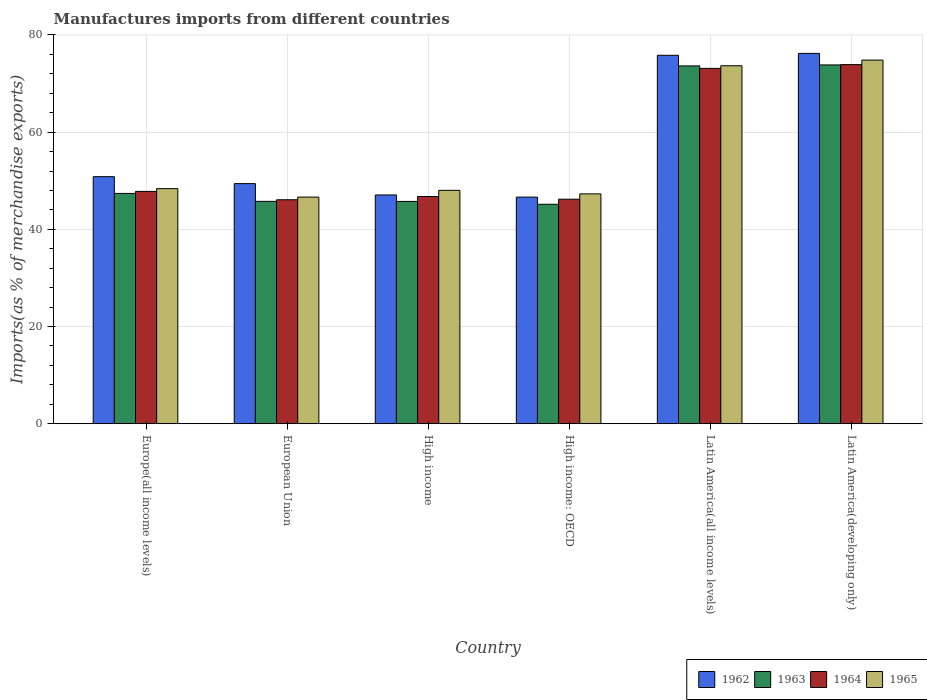How many different coloured bars are there?
Provide a succinct answer. 4. How many groups of bars are there?
Keep it short and to the point. 6. Are the number of bars per tick equal to the number of legend labels?
Your answer should be very brief. Yes. How many bars are there on the 4th tick from the left?
Offer a very short reply. 4. How many bars are there on the 1st tick from the right?
Give a very brief answer. 4. What is the label of the 6th group of bars from the left?
Provide a short and direct response. Latin America(developing only). In how many cases, is the number of bars for a given country not equal to the number of legend labels?
Provide a succinct answer. 0. What is the percentage of imports to different countries in 1964 in Latin America(all income levels)?
Offer a very short reply. 73.13. Across all countries, what is the maximum percentage of imports to different countries in 1965?
Your answer should be very brief. 74.83. Across all countries, what is the minimum percentage of imports to different countries in 1962?
Provide a succinct answer. 46.64. In which country was the percentage of imports to different countries in 1964 maximum?
Make the answer very short. Latin America(developing only). In which country was the percentage of imports to different countries in 1962 minimum?
Provide a short and direct response. High income: OECD. What is the total percentage of imports to different countries in 1963 in the graph?
Your response must be concise. 331.54. What is the difference between the percentage of imports to different countries in 1963 in Europe(all income levels) and that in High income?
Provide a succinct answer. 1.65. What is the difference between the percentage of imports to different countries in 1962 in Latin America(all income levels) and the percentage of imports to different countries in 1964 in High income?
Offer a terse response. 29.05. What is the average percentage of imports to different countries in 1962 per country?
Make the answer very short. 57.67. What is the difference between the percentage of imports to different countries of/in 1965 and percentage of imports to different countries of/in 1964 in European Union?
Provide a short and direct response. 0.55. In how many countries, is the percentage of imports to different countries in 1964 greater than 68 %?
Your response must be concise. 2. What is the ratio of the percentage of imports to different countries in 1962 in High income: OECD to that in Latin America(developing only)?
Give a very brief answer. 0.61. What is the difference between the highest and the second highest percentage of imports to different countries in 1963?
Your answer should be very brief. -0.2. What is the difference between the highest and the lowest percentage of imports to different countries in 1964?
Offer a terse response. 27.81. In how many countries, is the percentage of imports to different countries in 1962 greater than the average percentage of imports to different countries in 1962 taken over all countries?
Provide a succinct answer. 2. Is the sum of the percentage of imports to different countries in 1965 in European Union and Latin America(all income levels) greater than the maximum percentage of imports to different countries in 1962 across all countries?
Ensure brevity in your answer.  Yes. What does the 4th bar from the left in High income represents?
Make the answer very short. 1965. What does the 3rd bar from the right in High income: OECD represents?
Your answer should be very brief. 1963. Are all the bars in the graph horizontal?
Ensure brevity in your answer.  No. How many countries are there in the graph?
Ensure brevity in your answer.  6. Are the values on the major ticks of Y-axis written in scientific E-notation?
Offer a very short reply. No. Does the graph contain any zero values?
Offer a terse response. No. Does the graph contain grids?
Provide a succinct answer. Yes. Where does the legend appear in the graph?
Your response must be concise. Bottom right. How many legend labels are there?
Offer a terse response. 4. How are the legend labels stacked?
Your answer should be very brief. Horizontal. What is the title of the graph?
Your response must be concise. Manufactures imports from different countries. What is the label or title of the Y-axis?
Keep it short and to the point. Imports(as % of merchandise exports). What is the Imports(as % of merchandise exports) in 1962 in Europe(all income levels)?
Your answer should be very brief. 50.84. What is the Imports(as % of merchandise exports) in 1963 in Europe(all income levels)?
Provide a succinct answer. 47.4. What is the Imports(as % of merchandise exports) of 1964 in Europe(all income levels)?
Ensure brevity in your answer.  47.81. What is the Imports(as % of merchandise exports) in 1965 in Europe(all income levels)?
Offer a very short reply. 48.38. What is the Imports(as % of merchandise exports) in 1962 in European Union?
Your answer should be very brief. 49.41. What is the Imports(as % of merchandise exports) in 1963 in European Union?
Offer a very short reply. 45.76. What is the Imports(as % of merchandise exports) of 1964 in European Union?
Your answer should be very brief. 46.09. What is the Imports(as % of merchandise exports) of 1965 in European Union?
Your answer should be compact. 46.64. What is the Imports(as % of merchandise exports) in 1962 in High income?
Provide a short and direct response. 47.08. What is the Imports(as % of merchandise exports) of 1963 in High income?
Provide a short and direct response. 45.75. What is the Imports(as % of merchandise exports) in 1964 in High income?
Your response must be concise. 46.77. What is the Imports(as % of merchandise exports) of 1965 in High income?
Your answer should be compact. 48.04. What is the Imports(as % of merchandise exports) in 1962 in High income: OECD?
Offer a terse response. 46.64. What is the Imports(as % of merchandise exports) in 1963 in High income: OECD?
Your answer should be compact. 45.16. What is the Imports(as % of merchandise exports) of 1964 in High income: OECD?
Provide a succinct answer. 46.21. What is the Imports(as % of merchandise exports) of 1965 in High income: OECD?
Provide a short and direct response. 47.3. What is the Imports(as % of merchandise exports) in 1962 in Latin America(all income levels)?
Offer a terse response. 75.82. What is the Imports(as % of merchandise exports) in 1963 in Latin America(all income levels)?
Keep it short and to the point. 73.64. What is the Imports(as % of merchandise exports) of 1964 in Latin America(all income levels)?
Ensure brevity in your answer.  73.13. What is the Imports(as % of merchandise exports) of 1965 in Latin America(all income levels)?
Provide a short and direct response. 73.67. What is the Imports(as % of merchandise exports) of 1962 in Latin America(developing only)?
Offer a very short reply. 76.21. What is the Imports(as % of merchandise exports) in 1963 in Latin America(developing only)?
Offer a terse response. 73.84. What is the Imports(as % of merchandise exports) of 1964 in Latin America(developing only)?
Provide a succinct answer. 73.9. What is the Imports(as % of merchandise exports) of 1965 in Latin America(developing only)?
Ensure brevity in your answer.  74.83. Across all countries, what is the maximum Imports(as % of merchandise exports) of 1962?
Your answer should be compact. 76.21. Across all countries, what is the maximum Imports(as % of merchandise exports) in 1963?
Your response must be concise. 73.84. Across all countries, what is the maximum Imports(as % of merchandise exports) of 1964?
Your response must be concise. 73.9. Across all countries, what is the maximum Imports(as % of merchandise exports) of 1965?
Provide a short and direct response. 74.83. Across all countries, what is the minimum Imports(as % of merchandise exports) in 1962?
Provide a short and direct response. 46.64. Across all countries, what is the minimum Imports(as % of merchandise exports) of 1963?
Your response must be concise. 45.16. Across all countries, what is the minimum Imports(as % of merchandise exports) of 1964?
Your response must be concise. 46.09. Across all countries, what is the minimum Imports(as % of merchandise exports) of 1965?
Offer a very short reply. 46.64. What is the total Imports(as % of merchandise exports) of 1962 in the graph?
Provide a succinct answer. 346. What is the total Imports(as % of merchandise exports) in 1963 in the graph?
Your answer should be compact. 331.54. What is the total Imports(as % of merchandise exports) in 1964 in the graph?
Keep it short and to the point. 333.9. What is the total Imports(as % of merchandise exports) of 1965 in the graph?
Provide a short and direct response. 338.86. What is the difference between the Imports(as % of merchandise exports) in 1962 in Europe(all income levels) and that in European Union?
Offer a very short reply. 1.43. What is the difference between the Imports(as % of merchandise exports) in 1963 in Europe(all income levels) and that in European Union?
Ensure brevity in your answer.  1.63. What is the difference between the Imports(as % of merchandise exports) in 1964 in Europe(all income levels) and that in European Union?
Your answer should be very brief. 1.72. What is the difference between the Imports(as % of merchandise exports) in 1965 in Europe(all income levels) and that in European Union?
Offer a terse response. 1.74. What is the difference between the Imports(as % of merchandise exports) in 1962 in Europe(all income levels) and that in High income?
Keep it short and to the point. 3.76. What is the difference between the Imports(as % of merchandise exports) of 1963 in Europe(all income levels) and that in High income?
Offer a terse response. 1.65. What is the difference between the Imports(as % of merchandise exports) in 1964 in Europe(all income levels) and that in High income?
Make the answer very short. 1.05. What is the difference between the Imports(as % of merchandise exports) in 1965 in Europe(all income levels) and that in High income?
Offer a very short reply. 0.35. What is the difference between the Imports(as % of merchandise exports) in 1962 in Europe(all income levels) and that in High income: OECD?
Give a very brief answer. 4.21. What is the difference between the Imports(as % of merchandise exports) of 1963 in Europe(all income levels) and that in High income: OECD?
Provide a succinct answer. 2.23. What is the difference between the Imports(as % of merchandise exports) in 1964 in Europe(all income levels) and that in High income: OECD?
Provide a short and direct response. 1.61. What is the difference between the Imports(as % of merchandise exports) of 1965 in Europe(all income levels) and that in High income: OECD?
Your answer should be very brief. 1.08. What is the difference between the Imports(as % of merchandise exports) of 1962 in Europe(all income levels) and that in Latin America(all income levels)?
Your answer should be very brief. -24.98. What is the difference between the Imports(as % of merchandise exports) in 1963 in Europe(all income levels) and that in Latin America(all income levels)?
Ensure brevity in your answer.  -26.24. What is the difference between the Imports(as % of merchandise exports) of 1964 in Europe(all income levels) and that in Latin America(all income levels)?
Keep it short and to the point. -25.31. What is the difference between the Imports(as % of merchandise exports) in 1965 in Europe(all income levels) and that in Latin America(all income levels)?
Offer a terse response. -25.29. What is the difference between the Imports(as % of merchandise exports) in 1962 in Europe(all income levels) and that in Latin America(developing only)?
Your answer should be compact. -25.37. What is the difference between the Imports(as % of merchandise exports) in 1963 in Europe(all income levels) and that in Latin America(developing only)?
Make the answer very short. -26.44. What is the difference between the Imports(as % of merchandise exports) of 1964 in Europe(all income levels) and that in Latin America(developing only)?
Keep it short and to the point. -26.09. What is the difference between the Imports(as % of merchandise exports) in 1965 in Europe(all income levels) and that in Latin America(developing only)?
Provide a succinct answer. -26.45. What is the difference between the Imports(as % of merchandise exports) in 1962 in European Union and that in High income?
Keep it short and to the point. 2.33. What is the difference between the Imports(as % of merchandise exports) in 1963 in European Union and that in High income?
Your answer should be very brief. 0.02. What is the difference between the Imports(as % of merchandise exports) of 1964 in European Union and that in High income?
Make the answer very short. -0.68. What is the difference between the Imports(as % of merchandise exports) in 1965 in European Union and that in High income?
Make the answer very short. -1.4. What is the difference between the Imports(as % of merchandise exports) in 1962 in European Union and that in High income: OECD?
Ensure brevity in your answer.  2.78. What is the difference between the Imports(as % of merchandise exports) in 1963 in European Union and that in High income: OECD?
Your answer should be compact. 0.6. What is the difference between the Imports(as % of merchandise exports) in 1964 in European Union and that in High income: OECD?
Your answer should be compact. -0.12. What is the difference between the Imports(as % of merchandise exports) of 1965 in European Union and that in High income: OECD?
Provide a succinct answer. -0.67. What is the difference between the Imports(as % of merchandise exports) in 1962 in European Union and that in Latin America(all income levels)?
Provide a succinct answer. -26.4. What is the difference between the Imports(as % of merchandise exports) in 1963 in European Union and that in Latin America(all income levels)?
Keep it short and to the point. -27.87. What is the difference between the Imports(as % of merchandise exports) in 1964 in European Union and that in Latin America(all income levels)?
Keep it short and to the point. -27.04. What is the difference between the Imports(as % of merchandise exports) of 1965 in European Union and that in Latin America(all income levels)?
Keep it short and to the point. -27.03. What is the difference between the Imports(as % of merchandise exports) of 1962 in European Union and that in Latin America(developing only)?
Keep it short and to the point. -26.8. What is the difference between the Imports(as % of merchandise exports) of 1963 in European Union and that in Latin America(developing only)?
Give a very brief answer. -28.07. What is the difference between the Imports(as % of merchandise exports) in 1964 in European Union and that in Latin America(developing only)?
Provide a short and direct response. -27.81. What is the difference between the Imports(as % of merchandise exports) in 1965 in European Union and that in Latin America(developing only)?
Your response must be concise. -28.19. What is the difference between the Imports(as % of merchandise exports) of 1962 in High income and that in High income: OECD?
Ensure brevity in your answer.  0.44. What is the difference between the Imports(as % of merchandise exports) of 1963 in High income and that in High income: OECD?
Ensure brevity in your answer.  0.58. What is the difference between the Imports(as % of merchandise exports) in 1964 in High income and that in High income: OECD?
Offer a very short reply. 0.56. What is the difference between the Imports(as % of merchandise exports) of 1965 in High income and that in High income: OECD?
Offer a terse response. 0.73. What is the difference between the Imports(as % of merchandise exports) in 1962 in High income and that in Latin America(all income levels)?
Make the answer very short. -28.74. What is the difference between the Imports(as % of merchandise exports) of 1963 in High income and that in Latin America(all income levels)?
Your answer should be very brief. -27.89. What is the difference between the Imports(as % of merchandise exports) of 1964 in High income and that in Latin America(all income levels)?
Provide a succinct answer. -26.36. What is the difference between the Imports(as % of merchandise exports) of 1965 in High income and that in Latin America(all income levels)?
Make the answer very short. -25.63. What is the difference between the Imports(as % of merchandise exports) of 1962 in High income and that in Latin America(developing only)?
Provide a short and direct response. -29.13. What is the difference between the Imports(as % of merchandise exports) in 1963 in High income and that in Latin America(developing only)?
Offer a terse response. -28.09. What is the difference between the Imports(as % of merchandise exports) in 1964 in High income and that in Latin America(developing only)?
Make the answer very short. -27.13. What is the difference between the Imports(as % of merchandise exports) of 1965 in High income and that in Latin America(developing only)?
Give a very brief answer. -26.8. What is the difference between the Imports(as % of merchandise exports) of 1962 in High income: OECD and that in Latin America(all income levels)?
Keep it short and to the point. -29.18. What is the difference between the Imports(as % of merchandise exports) of 1963 in High income: OECD and that in Latin America(all income levels)?
Ensure brevity in your answer.  -28.47. What is the difference between the Imports(as % of merchandise exports) in 1964 in High income: OECD and that in Latin America(all income levels)?
Provide a succinct answer. -26.92. What is the difference between the Imports(as % of merchandise exports) in 1965 in High income: OECD and that in Latin America(all income levels)?
Offer a very short reply. -26.36. What is the difference between the Imports(as % of merchandise exports) of 1962 in High income: OECD and that in Latin America(developing only)?
Your answer should be very brief. -29.58. What is the difference between the Imports(as % of merchandise exports) in 1963 in High income: OECD and that in Latin America(developing only)?
Give a very brief answer. -28.67. What is the difference between the Imports(as % of merchandise exports) of 1964 in High income: OECD and that in Latin America(developing only)?
Your answer should be compact. -27.69. What is the difference between the Imports(as % of merchandise exports) of 1965 in High income: OECD and that in Latin America(developing only)?
Keep it short and to the point. -27.53. What is the difference between the Imports(as % of merchandise exports) of 1962 in Latin America(all income levels) and that in Latin America(developing only)?
Give a very brief answer. -0.39. What is the difference between the Imports(as % of merchandise exports) in 1963 in Latin America(all income levels) and that in Latin America(developing only)?
Offer a terse response. -0.2. What is the difference between the Imports(as % of merchandise exports) in 1964 in Latin America(all income levels) and that in Latin America(developing only)?
Your response must be concise. -0.77. What is the difference between the Imports(as % of merchandise exports) in 1965 in Latin America(all income levels) and that in Latin America(developing only)?
Ensure brevity in your answer.  -1.16. What is the difference between the Imports(as % of merchandise exports) in 1962 in Europe(all income levels) and the Imports(as % of merchandise exports) in 1963 in European Union?
Offer a terse response. 5.08. What is the difference between the Imports(as % of merchandise exports) of 1962 in Europe(all income levels) and the Imports(as % of merchandise exports) of 1964 in European Union?
Your response must be concise. 4.75. What is the difference between the Imports(as % of merchandise exports) of 1962 in Europe(all income levels) and the Imports(as % of merchandise exports) of 1965 in European Union?
Offer a very short reply. 4.2. What is the difference between the Imports(as % of merchandise exports) of 1963 in Europe(all income levels) and the Imports(as % of merchandise exports) of 1964 in European Union?
Provide a short and direct response. 1.31. What is the difference between the Imports(as % of merchandise exports) of 1963 in Europe(all income levels) and the Imports(as % of merchandise exports) of 1965 in European Union?
Offer a very short reply. 0.76. What is the difference between the Imports(as % of merchandise exports) of 1964 in Europe(all income levels) and the Imports(as % of merchandise exports) of 1965 in European Union?
Your answer should be compact. 1.18. What is the difference between the Imports(as % of merchandise exports) of 1962 in Europe(all income levels) and the Imports(as % of merchandise exports) of 1963 in High income?
Provide a succinct answer. 5.1. What is the difference between the Imports(as % of merchandise exports) of 1962 in Europe(all income levels) and the Imports(as % of merchandise exports) of 1964 in High income?
Keep it short and to the point. 4.08. What is the difference between the Imports(as % of merchandise exports) in 1962 in Europe(all income levels) and the Imports(as % of merchandise exports) in 1965 in High income?
Give a very brief answer. 2.81. What is the difference between the Imports(as % of merchandise exports) of 1963 in Europe(all income levels) and the Imports(as % of merchandise exports) of 1964 in High income?
Offer a very short reply. 0.63. What is the difference between the Imports(as % of merchandise exports) in 1963 in Europe(all income levels) and the Imports(as % of merchandise exports) in 1965 in High income?
Offer a very short reply. -0.64. What is the difference between the Imports(as % of merchandise exports) in 1964 in Europe(all income levels) and the Imports(as % of merchandise exports) in 1965 in High income?
Provide a succinct answer. -0.22. What is the difference between the Imports(as % of merchandise exports) in 1962 in Europe(all income levels) and the Imports(as % of merchandise exports) in 1963 in High income: OECD?
Provide a succinct answer. 5.68. What is the difference between the Imports(as % of merchandise exports) in 1962 in Europe(all income levels) and the Imports(as % of merchandise exports) in 1964 in High income: OECD?
Your answer should be very brief. 4.63. What is the difference between the Imports(as % of merchandise exports) of 1962 in Europe(all income levels) and the Imports(as % of merchandise exports) of 1965 in High income: OECD?
Give a very brief answer. 3.54. What is the difference between the Imports(as % of merchandise exports) in 1963 in Europe(all income levels) and the Imports(as % of merchandise exports) in 1964 in High income: OECD?
Make the answer very short. 1.19. What is the difference between the Imports(as % of merchandise exports) of 1963 in Europe(all income levels) and the Imports(as % of merchandise exports) of 1965 in High income: OECD?
Keep it short and to the point. 0.09. What is the difference between the Imports(as % of merchandise exports) in 1964 in Europe(all income levels) and the Imports(as % of merchandise exports) in 1965 in High income: OECD?
Offer a very short reply. 0.51. What is the difference between the Imports(as % of merchandise exports) of 1962 in Europe(all income levels) and the Imports(as % of merchandise exports) of 1963 in Latin America(all income levels)?
Provide a short and direct response. -22.79. What is the difference between the Imports(as % of merchandise exports) in 1962 in Europe(all income levels) and the Imports(as % of merchandise exports) in 1964 in Latin America(all income levels)?
Keep it short and to the point. -22.28. What is the difference between the Imports(as % of merchandise exports) in 1962 in Europe(all income levels) and the Imports(as % of merchandise exports) in 1965 in Latin America(all income levels)?
Keep it short and to the point. -22.83. What is the difference between the Imports(as % of merchandise exports) in 1963 in Europe(all income levels) and the Imports(as % of merchandise exports) in 1964 in Latin America(all income levels)?
Ensure brevity in your answer.  -25.73. What is the difference between the Imports(as % of merchandise exports) of 1963 in Europe(all income levels) and the Imports(as % of merchandise exports) of 1965 in Latin America(all income levels)?
Provide a short and direct response. -26.27. What is the difference between the Imports(as % of merchandise exports) of 1964 in Europe(all income levels) and the Imports(as % of merchandise exports) of 1965 in Latin America(all income levels)?
Give a very brief answer. -25.86. What is the difference between the Imports(as % of merchandise exports) in 1962 in Europe(all income levels) and the Imports(as % of merchandise exports) in 1963 in Latin America(developing only)?
Your response must be concise. -23. What is the difference between the Imports(as % of merchandise exports) in 1962 in Europe(all income levels) and the Imports(as % of merchandise exports) in 1964 in Latin America(developing only)?
Provide a short and direct response. -23.06. What is the difference between the Imports(as % of merchandise exports) of 1962 in Europe(all income levels) and the Imports(as % of merchandise exports) of 1965 in Latin America(developing only)?
Your response must be concise. -23.99. What is the difference between the Imports(as % of merchandise exports) in 1963 in Europe(all income levels) and the Imports(as % of merchandise exports) in 1964 in Latin America(developing only)?
Provide a succinct answer. -26.5. What is the difference between the Imports(as % of merchandise exports) of 1963 in Europe(all income levels) and the Imports(as % of merchandise exports) of 1965 in Latin America(developing only)?
Your answer should be compact. -27.44. What is the difference between the Imports(as % of merchandise exports) of 1964 in Europe(all income levels) and the Imports(as % of merchandise exports) of 1965 in Latin America(developing only)?
Offer a very short reply. -27.02. What is the difference between the Imports(as % of merchandise exports) in 1962 in European Union and the Imports(as % of merchandise exports) in 1963 in High income?
Your response must be concise. 3.67. What is the difference between the Imports(as % of merchandise exports) of 1962 in European Union and the Imports(as % of merchandise exports) of 1964 in High income?
Keep it short and to the point. 2.65. What is the difference between the Imports(as % of merchandise exports) of 1962 in European Union and the Imports(as % of merchandise exports) of 1965 in High income?
Give a very brief answer. 1.38. What is the difference between the Imports(as % of merchandise exports) in 1963 in European Union and the Imports(as % of merchandise exports) in 1964 in High income?
Ensure brevity in your answer.  -1. What is the difference between the Imports(as % of merchandise exports) of 1963 in European Union and the Imports(as % of merchandise exports) of 1965 in High income?
Make the answer very short. -2.27. What is the difference between the Imports(as % of merchandise exports) in 1964 in European Union and the Imports(as % of merchandise exports) in 1965 in High income?
Offer a terse response. -1.94. What is the difference between the Imports(as % of merchandise exports) of 1962 in European Union and the Imports(as % of merchandise exports) of 1963 in High income: OECD?
Make the answer very short. 4.25. What is the difference between the Imports(as % of merchandise exports) of 1962 in European Union and the Imports(as % of merchandise exports) of 1964 in High income: OECD?
Your answer should be compact. 3.21. What is the difference between the Imports(as % of merchandise exports) of 1962 in European Union and the Imports(as % of merchandise exports) of 1965 in High income: OECD?
Offer a very short reply. 2.11. What is the difference between the Imports(as % of merchandise exports) of 1963 in European Union and the Imports(as % of merchandise exports) of 1964 in High income: OECD?
Make the answer very short. -0.44. What is the difference between the Imports(as % of merchandise exports) in 1963 in European Union and the Imports(as % of merchandise exports) in 1965 in High income: OECD?
Provide a succinct answer. -1.54. What is the difference between the Imports(as % of merchandise exports) in 1964 in European Union and the Imports(as % of merchandise exports) in 1965 in High income: OECD?
Provide a short and direct response. -1.21. What is the difference between the Imports(as % of merchandise exports) of 1962 in European Union and the Imports(as % of merchandise exports) of 1963 in Latin America(all income levels)?
Give a very brief answer. -24.22. What is the difference between the Imports(as % of merchandise exports) of 1962 in European Union and the Imports(as % of merchandise exports) of 1964 in Latin America(all income levels)?
Your answer should be very brief. -23.71. What is the difference between the Imports(as % of merchandise exports) in 1962 in European Union and the Imports(as % of merchandise exports) in 1965 in Latin America(all income levels)?
Keep it short and to the point. -24.25. What is the difference between the Imports(as % of merchandise exports) in 1963 in European Union and the Imports(as % of merchandise exports) in 1964 in Latin America(all income levels)?
Offer a very short reply. -27.36. What is the difference between the Imports(as % of merchandise exports) in 1963 in European Union and the Imports(as % of merchandise exports) in 1965 in Latin America(all income levels)?
Make the answer very short. -27.91. What is the difference between the Imports(as % of merchandise exports) of 1964 in European Union and the Imports(as % of merchandise exports) of 1965 in Latin America(all income levels)?
Your answer should be compact. -27.58. What is the difference between the Imports(as % of merchandise exports) in 1962 in European Union and the Imports(as % of merchandise exports) in 1963 in Latin America(developing only)?
Provide a succinct answer. -24.42. What is the difference between the Imports(as % of merchandise exports) of 1962 in European Union and the Imports(as % of merchandise exports) of 1964 in Latin America(developing only)?
Make the answer very short. -24.49. What is the difference between the Imports(as % of merchandise exports) in 1962 in European Union and the Imports(as % of merchandise exports) in 1965 in Latin America(developing only)?
Provide a short and direct response. -25.42. What is the difference between the Imports(as % of merchandise exports) of 1963 in European Union and the Imports(as % of merchandise exports) of 1964 in Latin America(developing only)?
Your answer should be very brief. -28.14. What is the difference between the Imports(as % of merchandise exports) in 1963 in European Union and the Imports(as % of merchandise exports) in 1965 in Latin America(developing only)?
Your response must be concise. -29.07. What is the difference between the Imports(as % of merchandise exports) in 1964 in European Union and the Imports(as % of merchandise exports) in 1965 in Latin America(developing only)?
Provide a succinct answer. -28.74. What is the difference between the Imports(as % of merchandise exports) of 1962 in High income and the Imports(as % of merchandise exports) of 1963 in High income: OECD?
Give a very brief answer. 1.92. What is the difference between the Imports(as % of merchandise exports) in 1962 in High income and the Imports(as % of merchandise exports) in 1964 in High income: OECD?
Make the answer very short. 0.87. What is the difference between the Imports(as % of merchandise exports) of 1962 in High income and the Imports(as % of merchandise exports) of 1965 in High income: OECD?
Provide a succinct answer. -0.22. What is the difference between the Imports(as % of merchandise exports) of 1963 in High income and the Imports(as % of merchandise exports) of 1964 in High income: OECD?
Your response must be concise. -0.46. What is the difference between the Imports(as % of merchandise exports) of 1963 in High income and the Imports(as % of merchandise exports) of 1965 in High income: OECD?
Offer a very short reply. -1.56. What is the difference between the Imports(as % of merchandise exports) in 1964 in High income and the Imports(as % of merchandise exports) in 1965 in High income: OECD?
Your response must be concise. -0.54. What is the difference between the Imports(as % of merchandise exports) in 1962 in High income and the Imports(as % of merchandise exports) in 1963 in Latin America(all income levels)?
Keep it short and to the point. -26.56. What is the difference between the Imports(as % of merchandise exports) in 1962 in High income and the Imports(as % of merchandise exports) in 1964 in Latin America(all income levels)?
Make the answer very short. -26.05. What is the difference between the Imports(as % of merchandise exports) of 1962 in High income and the Imports(as % of merchandise exports) of 1965 in Latin America(all income levels)?
Your response must be concise. -26.59. What is the difference between the Imports(as % of merchandise exports) of 1963 in High income and the Imports(as % of merchandise exports) of 1964 in Latin America(all income levels)?
Your answer should be compact. -27.38. What is the difference between the Imports(as % of merchandise exports) of 1963 in High income and the Imports(as % of merchandise exports) of 1965 in Latin America(all income levels)?
Provide a succinct answer. -27.92. What is the difference between the Imports(as % of merchandise exports) in 1964 in High income and the Imports(as % of merchandise exports) in 1965 in Latin America(all income levels)?
Keep it short and to the point. -26.9. What is the difference between the Imports(as % of merchandise exports) of 1962 in High income and the Imports(as % of merchandise exports) of 1963 in Latin America(developing only)?
Your response must be concise. -26.76. What is the difference between the Imports(as % of merchandise exports) in 1962 in High income and the Imports(as % of merchandise exports) in 1964 in Latin America(developing only)?
Keep it short and to the point. -26.82. What is the difference between the Imports(as % of merchandise exports) of 1962 in High income and the Imports(as % of merchandise exports) of 1965 in Latin America(developing only)?
Make the answer very short. -27.75. What is the difference between the Imports(as % of merchandise exports) in 1963 in High income and the Imports(as % of merchandise exports) in 1964 in Latin America(developing only)?
Your answer should be compact. -28.15. What is the difference between the Imports(as % of merchandise exports) in 1963 in High income and the Imports(as % of merchandise exports) in 1965 in Latin America(developing only)?
Keep it short and to the point. -29.09. What is the difference between the Imports(as % of merchandise exports) of 1964 in High income and the Imports(as % of merchandise exports) of 1965 in Latin America(developing only)?
Provide a short and direct response. -28.07. What is the difference between the Imports(as % of merchandise exports) of 1962 in High income: OECD and the Imports(as % of merchandise exports) of 1964 in Latin America(all income levels)?
Your response must be concise. -26.49. What is the difference between the Imports(as % of merchandise exports) of 1962 in High income: OECD and the Imports(as % of merchandise exports) of 1965 in Latin America(all income levels)?
Ensure brevity in your answer.  -27.03. What is the difference between the Imports(as % of merchandise exports) of 1963 in High income: OECD and the Imports(as % of merchandise exports) of 1964 in Latin America(all income levels)?
Your answer should be compact. -27.96. What is the difference between the Imports(as % of merchandise exports) in 1963 in High income: OECD and the Imports(as % of merchandise exports) in 1965 in Latin America(all income levels)?
Offer a very short reply. -28.5. What is the difference between the Imports(as % of merchandise exports) in 1964 in High income: OECD and the Imports(as % of merchandise exports) in 1965 in Latin America(all income levels)?
Offer a terse response. -27.46. What is the difference between the Imports(as % of merchandise exports) in 1962 in High income: OECD and the Imports(as % of merchandise exports) in 1963 in Latin America(developing only)?
Keep it short and to the point. -27.2. What is the difference between the Imports(as % of merchandise exports) of 1962 in High income: OECD and the Imports(as % of merchandise exports) of 1964 in Latin America(developing only)?
Your answer should be compact. -27.26. What is the difference between the Imports(as % of merchandise exports) of 1962 in High income: OECD and the Imports(as % of merchandise exports) of 1965 in Latin America(developing only)?
Provide a short and direct response. -28.2. What is the difference between the Imports(as % of merchandise exports) of 1963 in High income: OECD and the Imports(as % of merchandise exports) of 1964 in Latin America(developing only)?
Give a very brief answer. -28.74. What is the difference between the Imports(as % of merchandise exports) of 1963 in High income: OECD and the Imports(as % of merchandise exports) of 1965 in Latin America(developing only)?
Your answer should be compact. -29.67. What is the difference between the Imports(as % of merchandise exports) in 1964 in High income: OECD and the Imports(as % of merchandise exports) in 1965 in Latin America(developing only)?
Offer a terse response. -28.62. What is the difference between the Imports(as % of merchandise exports) in 1962 in Latin America(all income levels) and the Imports(as % of merchandise exports) in 1963 in Latin America(developing only)?
Give a very brief answer. 1.98. What is the difference between the Imports(as % of merchandise exports) of 1962 in Latin America(all income levels) and the Imports(as % of merchandise exports) of 1964 in Latin America(developing only)?
Ensure brevity in your answer.  1.92. What is the difference between the Imports(as % of merchandise exports) in 1962 in Latin America(all income levels) and the Imports(as % of merchandise exports) in 1965 in Latin America(developing only)?
Keep it short and to the point. 0.99. What is the difference between the Imports(as % of merchandise exports) of 1963 in Latin America(all income levels) and the Imports(as % of merchandise exports) of 1964 in Latin America(developing only)?
Your response must be concise. -0.26. What is the difference between the Imports(as % of merchandise exports) of 1963 in Latin America(all income levels) and the Imports(as % of merchandise exports) of 1965 in Latin America(developing only)?
Provide a succinct answer. -1.2. What is the difference between the Imports(as % of merchandise exports) of 1964 in Latin America(all income levels) and the Imports(as % of merchandise exports) of 1965 in Latin America(developing only)?
Offer a very short reply. -1.71. What is the average Imports(as % of merchandise exports) in 1962 per country?
Provide a short and direct response. 57.67. What is the average Imports(as % of merchandise exports) in 1963 per country?
Your response must be concise. 55.26. What is the average Imports(as % of merchandise exports) of 1964 per country?
Your answer should be very brief. 55.65. What is the average Imports(as % of merchandise exports) of 1965 per country?
Give a very brief answer. 56.48. What is the difference between the Imports(as % of merchandise exports) in 1962 and Imports(as % of merchandise exports) in 1963 in Europe(all income levels)?
Ensure brevity in your answer.  3.45. What is the difference between the Imports(as % of merchandise exports) in 1962 and Imports(as % of merchandise exports) in 1964 in Europe(all income levels)?
Offer a very short reply. 3.03. What is the difference between the Imports(as % of merchandise exports) of 1962 and Imports(as % of merchandise exports) of 1965 in Europe(all income levels)?
Provide a succinct answer. 2.46. What is the difference between the Imports(as % of merchandise exports) in 1963 and Imports(as % of merchandise exports) in 1964 in Europe(all income levels)?
Your answer should be compact. -0.42. What is the difference between the Imports(as % of merchandise exports) of 1963 and Imports(as % of merchandise exports) of 1965 in Europe(all income levels)?
Offer a terse response. -0.99. What is the difference between the Imports(as % of merchandise exports) in 1964 and Imports(as % of merchandise exports) in 1965 in Europe(all income levels)?
Your response must be concise. -0.57. What is the difference between the Imports(as % of merchandise exports) in 1962 and Imports(as % of merchandise exports) in 1963 in European Union?
Your answer should be very brief. 3.65. What is the difference between the Imports(as % of merchandise exports) of 1962 and Imports(as % of merchandise exports) of 1964 in European Union?
Make the answer very short. 3.32. What is the difference between the Imports(as % of merchandise exports) of 1962 and Imports(as % of merchandise exports) of 1965 in European Union?
Make the answer very short. 2.78. What is the difference between the Imports(as % of merchandise exports) of 1963 and Imports(as % of merchandise exports) of 1964 in European Union?
Provide a short and direct response. -0.33. What is the difference between the Imports(as % of merchandise exports) of 1963 and Imports(as % of merchandise exports) of 1965 in European Union?
Offer a terse response. -0.88. What is the difference between the Imports(as % of merchandise exports) in 1964 and Imports(as % of merchandise exports) in 1965 in European Union?
Keep it short and to the point. -0.55. What is the difference between the Imports(as % of merchandise exports) of 1962 and Imports(as % of merchandise exports) of 1963 in High income?
Your response must be concise. 1.33. What is the difference between the Imports(as % of merchandise exports) of 1962 and Imports(as % of merchandise exports) of 1964 in High income?
Your answer should be very brief. 0.31. What is the difference between the Imports(as % of merchandise exports) in 1962 and Imports(as % of merchandise exports) in 1965 in High income?
Keep it short and to the point. -0.96. What is the difference between the Imports(as % of merchandise exports) of 1963 and Imports(as % of merchandise exports) of 1964 in High income?
Your answer should be very brief. -1.02. What is the difference between the Imports(as % of merchandise exports) of 1963 and Imports(as % of merchandise exports) of 1965 in High income?
Your answer should be very brief. -2.29. What is the difference between the Imports(as % of merchandise exports) of 1964 and Imports(as % of merchandise exports) of 1965 in High income?
Ensure brevity in your answer.  -1.27. What is the difference between the Imports(as % of merchandise exports) of 1962 and Imports(as % of merchandise exports) of 1963 in High income: OECD?
Your answer should be compact. 1.47. What is the difference between the Imports(as % of merchandise exports) in 1962 and Imports(as % of merchandise exports) in 1964 in High income: OECD?
Provide a succinct answer. 0.43. What is the difference between the Imports(as % of merchandise exports) of 1962 and Imports(as % of merchandise exports) of 1965 in High income: OECD?
Give a very brief answer. -0.67. What is the difference between the Imports(as % of merchandise exports) in 1963 and Imports(as % of merchandise exports) in 1964 in High income: OECD?
Keep it short and to the point. -1.04. What is the difference between the Imports(as % of merchandise exports) in 1963 and Imports(as % of merchandise exports) in 1965 in High income: OECD?
Your answer should be compact. -2.14. What is the difference between the Imports(as % of merchandise exports) in 1964 and Imports(as % of merchandise exports) in 1965 in High income: OECD?
Ensure brevity in your answer.  -1.1. What is the difference between the Imports(as % of merchandise exports) of 1962 and Imports(as % of merchandise exports) of 1963 in Latin America(all income levels)?
Your response must be concise. 2.18. What is the difference between the Imports(as % of merchandise exports) in 1962 and Imports(as % of merchandise exports) in 1964 in Latin America(all income levels)?
Ensure brevity in your answer.  2.69. What is the difference between the Imports(as % of merchandise exports) in 1962 and Imports(as % of merchandise exports) in 1965 in Latin America(all income levels)?
Your response must be concise. 2.15. What is the difference between the Imports(as % of merchandise exports) of 1963 and Imports(as % of merchandise exports) of 1964 in Latin America(all income levels)?
Your response must be concise. 0.51. What is the difference between the Imports(as % of merchandise exports) of 1963 and Imports(as % of merchandise exports) of 1965 in Latin America(all income levels)?
Your answer should be compact. -0.03. What is the difference between the Imports(as % of merchandise exports) in 1964 and Imports(as % of merchandise exports) in 1965 in Latin America(all income levels)?
Provide a short and direct response. -0.54. What is the difference between the Imports(as % of merchandise exports) in 1962 and Imports(as % of merchandise exports) in 1963 in Latin America(developing only)?
Keep it short and to the point. 2.37. What is the difference between the Imports(as % of merchandise exports) in 1962 and Imports(as % of merchandise exports) in 1964 in Latin America(developing only)?
Make the answer very short. 2.31. What is the difference between the Imports(as % of merchandise exports) in 1962 and Imports(as % of merchandise exports) in 1965 in Latin America(developing only)?
Make the answer very short. 1.38. What is the difference between the Imports(as % of merchandise exports) in 1963 and Imports(as % of merchandise exports) in 1964 in Latin America(developing only)?
Your answer should be very brief. -0.06. What is the difference between the Imports(as % of merchandise exports) of 1963 and Imports(as % of merchandise exports) of 1965 in Latin America(developing only)?
Offer a very short reply. -0.99. What is the difference between the Imports(as % of merchandise exports) of 1964 and Imports(as % of merchandise exports) of 1965 in Latin America(developing only)?
Ensure brevity in your answer.  -0.93. What is the ratio of the Imports(as % of merchandise exports) in 1962 in Europe(all income levels) to that in European Union?
Ensure brevity in your answer.  1.03. What is the ratio of the Imports(as % of merchandise exports) in 1963 in Europe(all income levels) to that in European Union?
Provide a short and direct response. 1.04. What is the ratio of the Imports(as % of merchandise exports) of 1964 in Europe(all income levels) to that in European Union?
Your response must be concise. 1.04. What is the ratio of the Imports(as % of merchandise exports) of 1965 in Europe(all income levels) to that in European Union?
Give a very brief answer. 1.04. What is the ratio of the Imports(as % of merchandise exports) in 1962 in Europe(all income levels) to that in High income?
Make the answer very short. 1.08. What is the ratio of the Imports(as % of merchandise exports) of 1963 in Europe(all income levels) to that in High income?
Give a very brief answer. 1.04. What is the ratio of the Imports(as % of merchandise exports) in 1964 in Europe(all income levels) to that in High income?
Your response must be concise. 1.02. What is the ratio of the Imports(as % of merchandise exports) of 1965 in Europe(all income levels) to that in High income?
Offer a very short reply. 1.01. What is the ratio of the Imports(as % of merchandise exports) in 1962 in Europe(all income levels) to that in High income: OECD?
Provide a short and direct response. 1.09. What is the ratio of the Imports(as % of merchandise exports) in 1963 in Europe(all income levels) to that in High income: OECD?
Keep it short and to the point. 1.05. What is the ratio of the Imports(as % of merchandise exports) of 1964 in Europe(all income levels) to that in High income: OECD?
Offer a very short reply. 1.03. What is the ratio of the Imports(as % of merchandise exports) of 1965 in Europe(all income levels) to that in High income: OECD?
Offer a very short reply. 1.02. What is the ratio of the Imports(as % of merchandise exports) in 1962 in Europe(all income levels) to that in Latin America(all income levels)?
Ensure brevity in your answer.  0.67. What is the ratio of the Imports(as % of merchandise exports) in 1963 in Europe(all income levels) to that in Latin America(all income levels)?
Your response must be concise. 0.64. What is the ratio of the Imports(as % of merchandise exports) in 1964 in Europe(all income levels) to that in Latin America(all income levels)?
Your response must be concise. 0.65. What is the ratio of the Imports(as % of merchandise exports) of 1965 in Europe(all income levels) to that in Latin America(all income levels)?
Your answer should be very brief. 0.66. What is the ratio of the Imports(as % of merchandise exports) in 1962 in Europe(all income levels) to that in Latin America(developing only)?
Ensure brevity in your answer.  0.67. What is the ratio of the Imports(as % of merchandise exports) in 1963 in Europe(all income levels) to that in Latin America(developing only)?
Ensure brevity in your answer.  0.64. What is the ratio of the Imports(as % of merchandise exports) in 1964 in Europe(all income levels) to that in Latin America(developing only)?
Ensure brevity in your answer.  0.65. What is the ratio of the Imports(as % of merchandise exports) in 1965 in Europe(all income levels) to that in Latin America(developing only)?
Offer a terse response. 0.65. What is the ratio of the Imports(as % of merchandise exports) in 1962 in European Union to that in High income?
Make the answer very short. 1.05. What is the ratio of the Imports(as % of merchandise exports) of 1963 in European Union to that in High income?
Offer a terse response. 1. What is the ratio of the Imports(as % of merchandise exports) in 1964 in European Union to that in High income?
Offer a very short reply. 0.99. What is the ratio of the Imports(as % of merchandise exports) in 1965 in European Union to that in High income?
Provide a succinct answer. 0.97. What is the ratio of the Imports(as % of merchandise exports) in 1962 in European Union to that in High income: OECD?
Your response must be concise. 1.06. What is the ratio of the Imports(as % of merchandise exports) in 1963 in European Union to that in High income: OECD?
Your response must be concise. 1.01. What is the ratio of the Imports(as % of merchandise exports) in 1965 in European Union to that in High income: OECD?
Offer a very short reply. 0.99. What is the ratio of the Imports(as % of merchandise exports) in 1962 in European Union to that in Latin America(all income levels)?
Your response must be concise. 0.65. What is the ratio of the Imports(as % of merchandise exports) of 1963 in European Union to that in Latin America(all income levels)?
Ensure brevity in your answer.  0.62. What is the ratio of the Imports(as % of merchandise exports) of 1964 in European Union to that in Latin America(all income levels)?
Provide a short and direct response. 0.63. What is the ratio of the Imports(as % of merchandise exports) of 1965 in European Union to that in Latin America(all income levels)?
Your answer should be compact. 0.63. What is the ratio of the Imports(as % of merchandise exports) in 1962 in European Union to that in Latin America(developing only)?
Provide a short and direct response. 0.65. What is the ratio of the Imports(as % of merchandise exports) in 1963 in European Union to that in Latin America(developing only)?
Your answer should be compact. 0.62. What is the ratio of the Imports(as % of merchandise exports) in 1964 in European Union to that in Latin America(developing only)?
Provide a succinct answer. 0.62. What is the ratio of the Imports(as % of merchandise exports) in 1965 in European Union to that in Latin America(developing only)?
Offer a very short reply. 0.62. What is the ratio of the Imports(as % of merchandise exports) in 1962 in High income to that in High income: OECD?
Give a very brief answer. 1.01. What is the ratio of the Imports(as % of merchandise exports) of 1963 in High income to that in High income: OECD?
Your answer should be very brief. 1.01. What is the ratio of the Imports(as % of merchandise exports) in 1964 in High income to that in High income: OECD?
Your response must be concise. 1.01. What is the ratio of the Imports(as % of merchandise exports) in 1965 in High income to that in High income: OECD?
Give a very brief answer. 1.02. What is the ratio of the Imports(as % of merchandise exports) of 1962 in High income to that in Latin America(all income levels)?
Give a very brief answer. 0.62. What is the ratio of the Imports(as % of merchandise exports) of 1963 in High income to that in Latin America(all income levels)?
Your answer should be very brief. 0.62. What is the ratio of the Imports(as % of merchandise exports) in 1964 in High income to that in Latin America(all income levels)?
Offer a terse response. 0.64. What is the ratio of the Imports(as % of merchandise exports) in 1965 in High income to that in Latin America(all income levels)?
Offer a very short reply. 0.65. What is the ratio of the Imports(as % of merchandise exports) of 1962 in High income to that in Latin America(developing only)?
Your answer should be very brief. 0.62. What is the ratio of the Imports(as % of merchandise exports) of 1963 in High income to that in Latin America(developing only)?
Your answer should be compact. 0.62. What is the ratio of the Imports(as % of merchandise exports) of 1964 in High income to that in Latin America(developing only)?
Give a very brief answer. 0.63. What is the ratio of the Imports(as % of merchandise exports) of 1965 in High income to that in Latin America(developing only)?
Your answer should be compact. 0.64. What is the ratio of the Imports(as % of merchandise exports) in 1962 in High income: OECD to that in Latin America(all income levels)?
Give a very brief answer. 0.62. What is the ratio of the Imports(as % of merchandise exports) in 1963 in High income: OECD to that in Latin America(all income levels)?
Your answer should be compact. 0.61. What is the ratio of the Imports(as % of merchandise exports) of 1964 in High income: OECD to that in Latin America(all income levels)?
Your response must be concise. 0.63. What is the ratio of the Imports(as % of merchandise exports) of 1965 in High income: OECD to that in Latin America(all income levels)?
Your response must be concise. 0.64. What is the ratio of the Imports(as % of merchandise exports) of 1962 in High income: OECD to that in Latin America(developing only)?
Provide a succinct answer. 0.61. What is the ratio of the Imports(as % of merchandise exports) in 1963 in High income: OECD to that in Latin America(developing only)?
Offer a very short reply. 0.61. What is the ratio of the Imports(as % of merchandise exports) in 1964 in High income: OECD to that in Latin America(developing only)?
Ensure brevity in your answer.  0.63. What is the ratio of the Imports(as % of merchandise exports) in 1965 in High income: OECD to that in Latin America(developing only)?
Your answer should be compact. 0.63. What is the ratio of the Imports(as % of merchandise exports) in 1962 in Latin America(all income levels) to that in Latin America(developing only)?
Provide a succinct answer. 0.99. What is the ratio of the Imports(as % of merchandise exports) of 1963 in Latin America(all income levels) to that in Latin America(developing only)?
Provide a short and direct response. 1. What is the ratio of the Imports(as % of merchandise exports) of 1965 in Latin America(all income levels) to that in Latin America(developing only)?
Provide a short and direct response. 0.98. What is the difference between the highest and the second highest Imports(as % of merchandise exports) in 1962?
Your answer should be compact. 0.39. What is the difference between the highest and the second highest Imports(as % of merchandise exports) of 1963?
Give a very brief answer. 0.2. What is the difference between the highest and the second highest Imports(as % of merchandise exports) in 1964?
Your answer should be compact. 0.77. What is the difference between the highest and the second highest Imports(as % of merchandise exports) in 1965?
Your answer should be compact. 1.16. What is the difference between the highest and the lowest Imports(as % of merchandise exports) of 1962?
Your answer should be compact. 29.58. What is the difference between the highest and the lowest Imports(as % of merchandise exports) in 1963?
Keep it short and to the point. 28.67. What is the difference between the highest and the lowest Imports(as % of merchandise exports) of 1964?
Provide a short and direct response. 27.81. What is the difference between the highest and the lowest Imports(as % of merchandise exports) in 1965?
Make the answer very short. 28.19. 